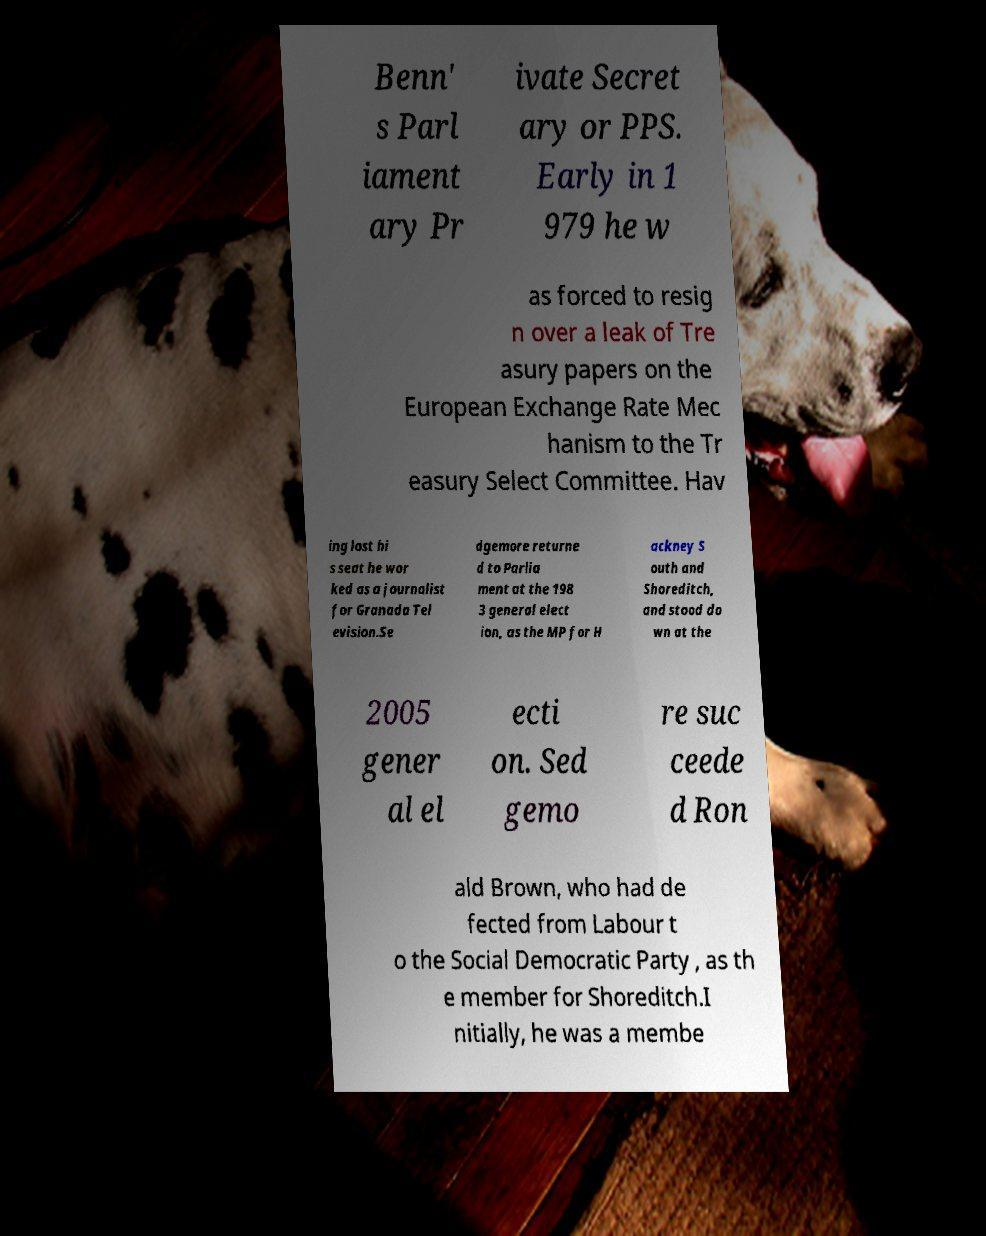Can you accurately transcribe the text from the provided image for me? Benn' s Parl iament ary Pr ivate Secret ary or PPS. Early in 1 979 he w as forced to resig n over a leak of Tre asury papers on the European Exchange Rate Mec hanism to the Tr easury Select Committee. Hav ing lost hi s seat he wor ked as a journalist for Granada Tel evision.Se dgemore returne d to Parlia ment at the 198 3 general elect ion, as the MP for H ackney S outh and Shoreditch, and stood do wn at the 2005 gener al el ecti on. Sed gemo re suc ceede d Ron ald Brown, who had de fected from Labour t o the Social Democratic Party , as th e member for Shoreditch.I nitially, he was a membe 